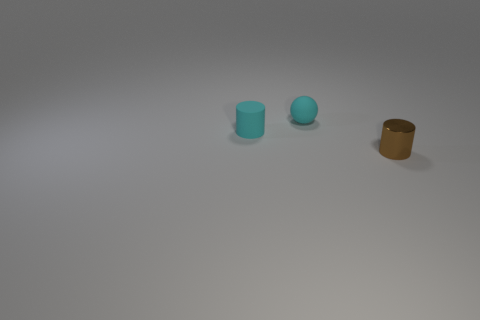Subtract all cyan cylinders. Subtract all cyan blocks. How many cylinders are left? 1 Add 2 small brown shiny cylinders. How many objects exist? 5 Subtract all cylinders. How many objects are left? 1 Subtract all small green blocks. Subtract all cyan spheres. How many objects are left? 2 Add 2 matte spheres. How many matte spheres are left? 3 Add 1 small purple balls. How many small purple balls exist? 1 Subtract 0 purple balls. How many objects are left? 3 